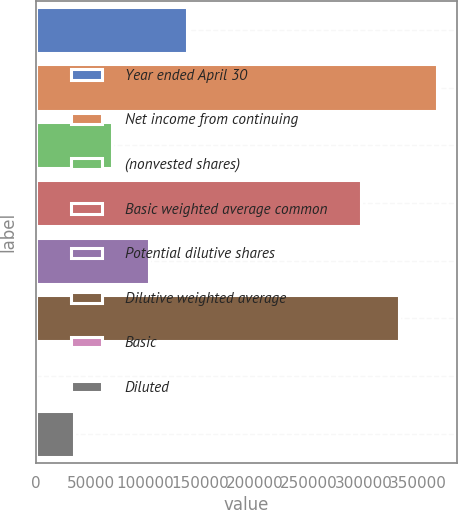<chart> <loc_0><loc_0><loc_500><loc_500><bar_chart><fcel>Year ended April 30<fcel>Net income from continuing<fcel>(nonvested shares)<fcel>Basic weighted average common<fcel>Potential dilutive shares<fcel>Dilutive weighted average<fcel>Basic<fcel>Diluted<nl><fcel>138388<fcel>367056<fcel>69194.5<fcel>297863<fcel>103791<fcel>332460<fcel>1.16<fcel>34597.8<nl></chart> 